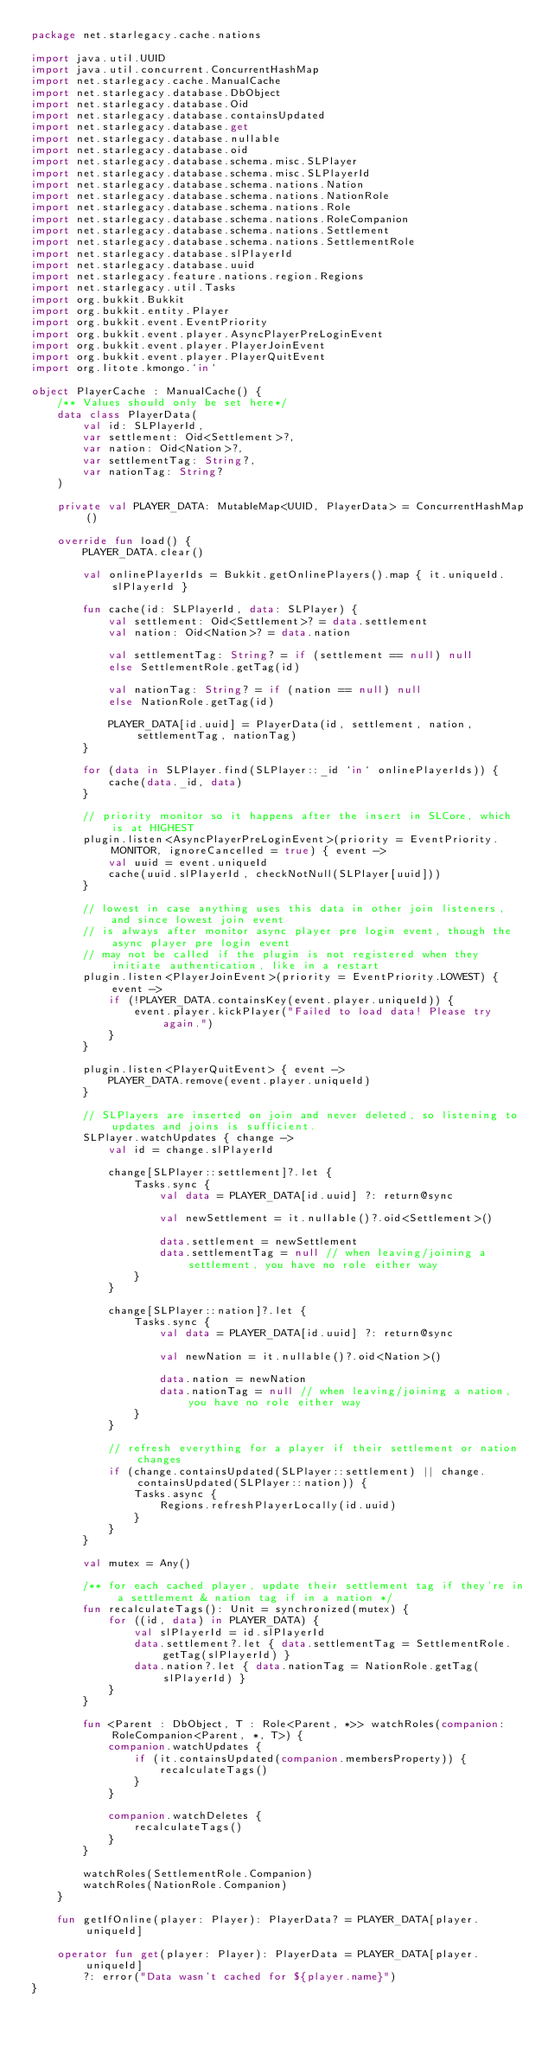<code> <loc_0><loc_0><loc_500><loc_500><_Kotlin_>package net.starlegacy.cache.nations

import java.util.UUID
import java.util.concurrent.ConcurrentHashMap
import net.starlegacy.cache.ManualCache
import net.starlegacy.database.DbObject
import net.starlegacy.database.Oid
import net.starlegacy.database.containsUpdated
import net.starlegacy.database.get
import net.starlegacy.database.nullable
import net.starlegacy.database.oid
import net.starlegacy.database.schema.misc.SLPlayer
import net.starlegacy.database.schema.misc.SLPlayerId
import net.starlegacy.database.schema.nations.Nation
import net.starlegacy.database.schema.nations.NationRole
import net.starlegacy.database.schema.nations.Role
import net.starlegacy.database.schema.nations.RoleCompanion
import net.starlegacy.database.schema.nations.Settlement
import net.starlegacy.database.schema.nations.SettlementRole
import net.starlegacy.database.slPlayerId
import net.starlegacy.database.uuid
import net.starlegacy.feature.nations.region.Regions
import net.starlegacy.util.Tasks
import org.bukkit.Bukkit
import org.bukkit.entity.Player
import org.bukkit.event.EventPriority
import org.bukkit.event.player.AsyncPlayerPreLoginEvent
import org.bukkit.event.player.PlayerJoinEvent
import org.bukkit.event.player.PlayerQuitEvent
import org.litote.kmongo.`in`

object PlayerCache : ManualCache() {
	/** Values should only be set here*/
	data class PlayerData(
		val id: SLPlayerId,
		var settlement: Oid<Settlement>?,
		var nation: Oid<Nation>?,
		var settlementTag: String?,
		var nationTag: String?
	)

	private val PLAYER_DATA: MutableMap<UUID, PlayerData> = ConcurrentHashMap()

	override fun load() {
		PLAYER_DATA.clear()

		val onlinePlayerIds = Bukkit.getOnlinePlayers().map { it.uniqueId.slPlayerId }

		fun cache(id: SLPlayerId, data: SLPlayer) {
			val settlement: Oid<Settlement>? = data.settlement
			val nation: Oid<Nation>? = data.nation

			val settlementTag: String? = if (settlement == null) null
			else SettlementRole.getTag(id)

			val nationTag: String? = if (nation == null) null
			else NationRole.getTag(id)

			PLAYER_DATA[id.uuid] = PlayerData(id, settlement, nation, settlementTag, nationTag)
		}

		for (data in SLPlayer.find(SLPlayer::_id `in` onlinePlayerIds)) {
			cache(data._id, data)
		}

		// priority monitor so it happens after the insert in SLCore, which is at HIGHEST
		plugin.listen<AsyncPlayerPreLoginEvent>(priority = EventPriority.MONITOR, ignoreCancelled = true) { event ->
			val uuid = event.uniqueId
			cache(uuid.slPlayerId, checkNotNull(SLPlayer[uuid]))
		}

		// lowest in case anything uses this data in other join listeners, and since lowest join event
		// is always after monitor async player pre login event, though the async player pre login event
		// may not be called if the plugin is not registered when they initiate authentication, like in a restart
		plugin.listen<PlayerJoinEvent>(priority = EventPriority.LOWEST) { event ->
			if (!PLAYER_DATA.containsKey(event.player.uniqueId)) {
				event.player.kickPlayer("Failed to load data! Please try again.")
			}
		}

		plugin.listen<PlayerQuitEvent> { event ->
			PLAYER_DATA.remove(event.player.uniqueId)
		}

		// SLPlayers are inserted on join and never deleted, so listening to updates and joins is sufficient.
		SLPlayer.watchUpdates { change ->
			val id = change.slPlayerId

			change[SLPlayer::settlement]?.let {
				Tasks.sync {
					val data = PLAYER_DATA[id.uuid] ?: return@sync

					val newSettlement = it.nullable()?.oid<Settlement>()

					data.settlement = newSettlement
					data.settlementTag = null // when leaving/joining a settlement, you have no role either way
				}
			}

			change[SLPlayer::nation]?.let {
				Tasks.sync {
					val data = PLAYER_DATA[id.uuid] ?: return@sync

					val newNation = it.nullable()?.oid<Nation>()

					data.nation = newNation
					data.nationTag = null // when leaving/joining a nation, you have no role either way
				}
			}

			// refresh everything for a player if their settlement or nation changes
			if (change.containsUpdated(SLPlayer::settlement) || change.containsUpdated(SLPlayer::nation)) {
				Tasks.async {
					Regions.refreshPlayerLocally(id.uuid)
				}
			}
		}

		val mutex = Any()

		/** for each cached player, update their settlement tag if they're in a settlement & nation tag if in a nation */
		fun recalculateTags(): Unit = synchronized(mutex) {
			for ((id, data) in PLAYER_DATA) {
				val slPlayerId = id.slPlayerId
				data.settlement?.let { data.settlementTag = SettlementRole.getTag(slPlayerId) }
				data.nation?.let { data.nationTag = NationRole.getTag(slPlayerId) }
			}
		}

		fun <Parent : DbObject, T : Role<Parent, *>> watchRoles(companion: RoleCompanion<Parent, *, T>) {
			companion.watchUpdates {
				if (it.containsUpdated(companion.membersProperty)) {
					recalculateTags()
				}
			}

			companion.watchDeletes {
				recalculateTags()
			}
		}

		watchRoles(SettlementRole.Companion)
		watchRoles(NationRole.Companion)
	}

	fun getIfOnline(player: Player): PlayerData? = PLAYER_DATA[player.uniqueId]

	operator fun get(player: Player): PlayerData = PLAYER_DATA[player.uniqueId]
		?: error("Data wasn't cached for ${player.name}")
}
</code> 